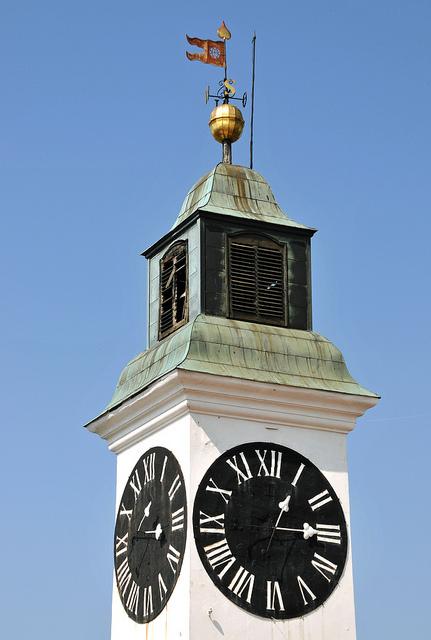Is there a rooster on the weathervane?
Write a very short answer. No. Are there shutters on the top of the clock?
Keep it brief. Yes. What time does the clock say?
Give a very brief answer. 1:15. 